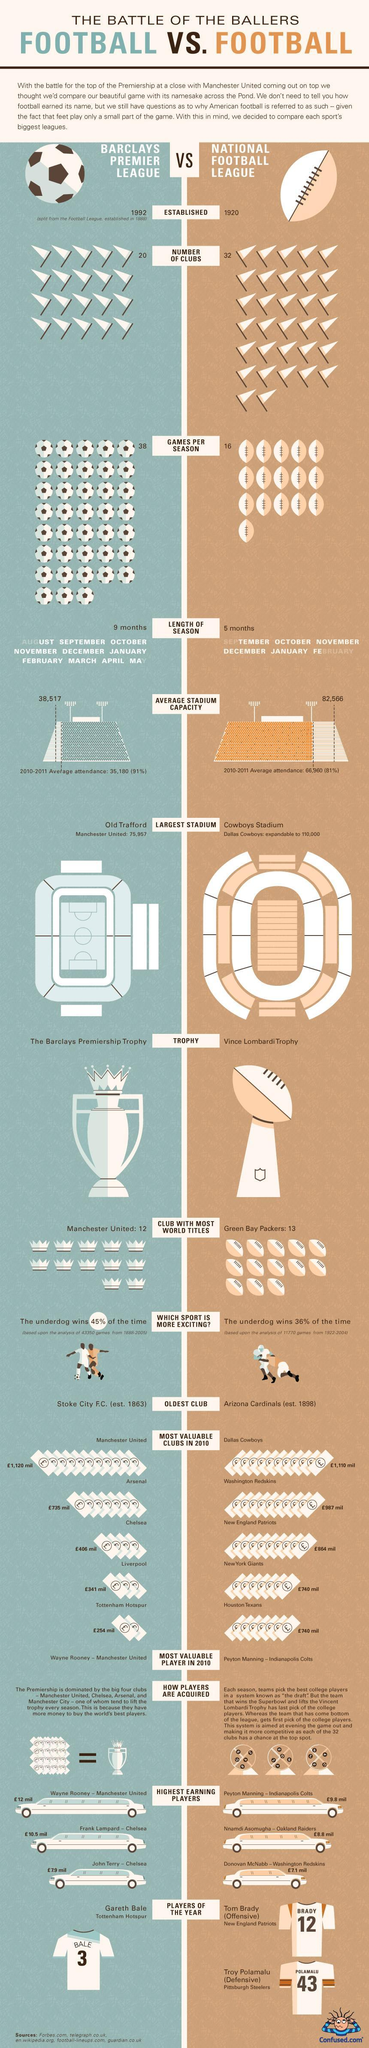How many games per season were played by the National Football League?
Answer the question with a short phrase. 16 Which is the home ground of Dallas Cowboys? Cowboys Stadium When was the National Football League established? 1920 Which club has won the most NFL Championships? Green Bay Packers How many clubs are there in the National Football League? 32 Which trophy is awarded to the winning team of National Football League's championship game? Vince Lombardi Trophy Which is the home ground of Manchester United? Old Trafford What is the average stadium capacity of NFL games? 82,566 Which club has won the most Barclays Premier League titles? Manchester United How many clubs are there in the Barclays Premier League? 20 